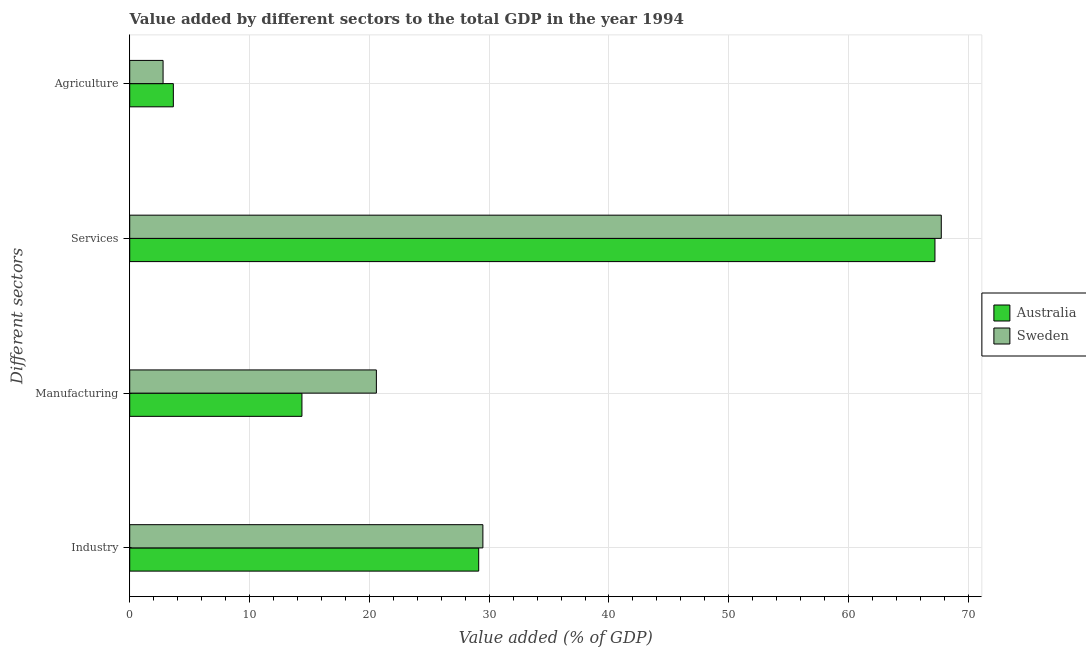How many different coloured bars are there?
Offer a very short reply. 2. How many groups of bars are there?
Make the answer very short. 4. How many bars are there on the 4th tick from the top?
Keep it short and to the point. 2. What is the label of the 1st group of bars from the top?
Your answer should be compact. Agriculture. What is the value added by manufacturing sector in Australia?
Provide a succinct answer. 14.37. Across all countries, what is the maximum value added by services sector?
Provide a short and direct response. 67.74. Across all countries, what is the minimum value added by manufacturing sector?
Provide a succinct answer. 14.37. In which country was the value added by industrial sector maximum?
Your answer should be compact. Sweden. What is the total value added by agricultural sector in the graph?
Your response must be concise. 6.42. What is the difference between the value added by manufacturing sector in Sweden and that in Australia?
Ensure brevity in your answer.  6.21. What is the difference between the value added by services sector in Sweden and the value added by agricultural sector in Australia?
Offer a very short reply. 64.1. What is the average value added by industrial sector per country?
Give a very brief answer. 29.3. What is the difference between the value added by agricultural sector and value added by services sector in Sweden?
Your answer should be very brief. -64.96. What is the ratio of the value added by industrial sector in Australia to that in Sweden?
Ensure brevity in your answer.  0.99. Is the difference between the value added by services sector in Australia and Sweden greater than the difference between the value added by manufacturing sector in Australia and Sweden?
Your answer should be very brief. Yes. What is the difference between the highest and the second highest value added by industrial sector?
Your answer should be compact. 0.35. What is the difference between the highest and the lowest value added by industrial sector?
Keep it short and to the point. 0.35. Is the sum of the value added by agricultural sector in Australia and Sweden greater than the maximum value added by industrial sector across all countries?
Ensure brevity in your answer.  No. Is it the case that in every country, the sum of the value added by manufacturing sector and value added by agricultural sector is greater than the sum of value added by services sector and value added by industrial sector?
Your answer should be very brief. No. What does the 1st bar from the bottom in Industry represents?
Your answer should be very brief. Australia. Is it the case that in every country, the sum of the value added by industrial sector and value added by manufacturing sector is greater than the value added by services sector?
Provide a succinct answer. No. How many bars are there?
Provide a succinct answer. 8. Are the values on the major ticks of X-axis written in scientific E-notation?
Your response must be concise. No. Does the graph contain any zero values?
Your response must be concise. No. Where does the legend appear in the graph?
Ensure brevity in your answer.  Center right. What is the title of the graph?
Offer a very short reply. Value added by different sectors to the total GDP in the year 1994. Does "Solomon Islands" appear as one of the legend labels in the graph?
Your answer should be very brief. No. What is the label or title of the X-axis?
Provide a succinct answer. Value added (% of GDP). What is the label or title of the Y-axis?
Provide a succinct answer. Different sectors. What is the Value added (% of GDP) in Australia in Industry?
Ensure brevity in your answer.  29.13. What is the Value added (% of GDP) in Sweden in Industry?
Your response must be concise. 29.48. What is the Value added (% of GDP) of Australia in Manufacturing?
Keep it short and to the point. 14.37. What is the Value added (% of GDP) of Sweden in Manufacturing?
Offer a very short reply. 20.59. What is the Value added (% of GDP) in Australia in Services?
Offer a terse response. 67.21. What is the Value added (% of GDP) in Sweden in Services?
Provide a short and direct response. 67.74. What is the Value added (% of GDP) of Australia in Agriculture?
Ensure brevity in your answer.  3.64. What is the Value added (% of GDP) in Sweden in Agriculture?
Your answer should be very brief. 2.78. Across all Different sectors, what is the maximum Value added (% of GDP) in Australia?
Keep it short and to the point. 67.21. Across all Different sectors, what is the maximum Value added (% of GDP) of Sweden?
Your answer should be compact. 67.74. Across all Different sectors, what is the minimum Value added (% of GDP) in Australia?
Offer a terse response. 3.64. Across all Different sectors, what is the minimum Value added (% of GDP) in Sweden?
Offer a terse response. 2.78. What is the total Value added (% of GDP) in Australia in the graph?
Make the answer very short. 114.35. What is the total Value added (% of GDP) in Sweden in the graph?
Provide a succinct answer. 120.59. What is the difference between the Value added (% of GDP) of Australia in Industry and that in Manufacturing?
Make the answer very short. 14.75. What is the difference between the Value added (% of GDP) of Sweden in Industry and that in Manufacturing?
Provide a succinct answer. 8.89. What is the difference between the Value added (% of GDP) of Australia in Industry and that in Services?
Provide a succinct answer. -38.08. What is the difference between the Value added (% of GDP) of Sweden in Industry and that in Services?
Offer a very short reply. -38.26. What is the difference between the Value added (% of GDP) in Australia in Industry and that in Agriculture?
Your answer should be very brief. 25.49. What is the difference between the Value added (% of GDP) of Sweden in Industry and that in Agriculture?
Give a very brief answer. 26.69. What is the difference between the Value added (% of GDP) of Australia in Manufacturing and that in Services?
Make the answer very short. -52.84. What is the difference between the Value added (% of GDP) in Sweden in Manufacturing and that in Services?
Your answer should be very brief. -47.15. What is the difference between the Value added (% of GDP) in Australia in Manufacturing and that in Agriculture?
Offer a terse response. 10.73. What is the difference between the Value added (% of GDP) in Sweden in Manufacturing and that in Agriculture?
Your response must be concise. 17.8. What is the difference between the Value added (% of GDP) in Australia in Services and that in Agriculture?
Your answer should be very brief. 63.57. What is the difference between the Value added (% of GDP) in Sweden in Services and that in Agriculture?
Offer a very short reply. 64.96. What is the difference between the Value added (% of GDP) of Australia in Industry and the Value added (% of GDP) of Sweden in Manufacturing?
Offer a very short reply. 8.54. What is the difference between the Value added (% of GDP) of Australia in Industry and the Value added (% of GDP) of Sweden in Services?
Your answer should be very brief. -38.61. What is the difference between the Value added (% of GDP) of Australia in Industry and the Value added (% of GDP) of Sweden in Agriculture?
Provide a short and direct response. 26.34. What is the difference between the Value added (% of GDP) in Australia in Manufacturing and the Value added (% of GDP) in Sweden in Services?
Give a very brief answer. -53.37. What is the difference between the Value added (% of GDP) of Australia in Manufacturing and the Value added (% of GDP) of Sweden in Agriculture?
Ensure brevity in your answer.  11.59. What is the difference between the Value added (% of GDP) of Australia in Services and the Value added (% of GDP) of Sweden in Agriculture?
Keep it short and to the point. 64.43. What is the average Value added (% of GDP) in Australia per Different sectors?
Give a very brief answer. 28.59. What is the average Value added (% of GDP) of Sweden per Different sectors?
Provide a short and direct response. 30.15. What is the difference between the Value added (% of GDP) in Australia and Value added (% of GDP) in Sweden in Industry?
Ensure brevity in your answer.  -0.35. What is the difference between the Value added (% of GDP) of Australia and Value added (% of GDP) of Sweden in Manufacturing?
Your answer should be very brief. -6.21. What is the difference between the Value added (% of GDP) of Australia and Value added (% of GDP) of Sweden in Services?
Provide a short and direct response. -0.53. What is the difference between the Value added (% of GDP) of Australia and Value added (% of GDP) of Sweden in Agriculture?
Your response must be concise. 0.86. What is the ratio of the Value added (% of GDP) of Australia in Industry to that in Manufacturing?
Ensure brevity in your answer.  2.03. What is the ratio of the Value added (% of GDP) of Sweden in Industry to that in Manufacturing?
Your answer should be very brief. 1.43. What is the ratio of the Value added (% of GDP) in Australia in Industry to that in Services?
Offer a terse response. 0.43. What is the ratio of the Value added (% of GDP) in Sweden in Industry to that in Services?
Make the answer very short. 0.44. What is the ratio of the Value added (% of GDP) in Australia in Industry to that in Agriculture?
Give a very brief answer. 8. What is the ratio of the Value added (% of GDP) of Sweden in Industry to that in Agriculture?
Your answer should be compact. 10.59. What is the ratio of the Value added (% of GDP) of Australia in Manufacturing to that in Services?
Ensure brevity in your answer.  0.21. What is the ratio of the Value added (% of GDP) of Sweden in Manufacturing to that in Services?
Offer a very short reply. 0.3. What is the ratio of the Value added (% of GDP) of Australia in Manufacturing to that in Agriculture?
Offer a very short reply. 3.95. What is the ratio of the Value added (% of GDP) in Sweden in Manufacturing to that in Agriculture?
Provide a succinct answer. 7.4. What is the ratio of the Value added (% of GDP) of Australia in Services to that in Agriculture?
Keep it short and to the point. 18.46. What is the ratio of the Value added (% of GDP) of Sweden in Services to that in Agriculture?
Your answer should be compact. 24.34. What is the difference between the highest and the second highest Value added (% of GDP) in Australia?
Provide a succinct answer. 38.08. What is the difference between the highest and the second highest Value added (% of GDP) in Sweden?
Offer a very short reply. 38.26. What is the difference between the highest and the lowest Value added (% of GDP) of Australia?
Offer a terse response. 63.57. What is the difference between the highest and the lowest Value added (% of GDP) of Sweden?
Provide a succinct answer. 64.96. 